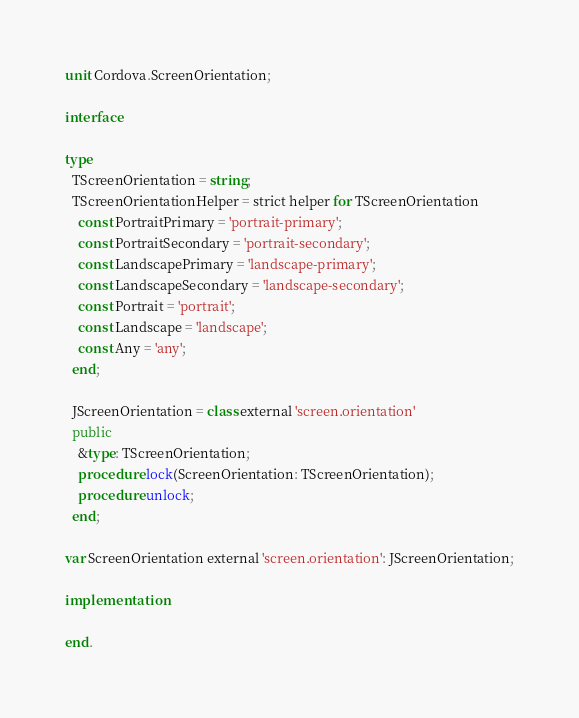Convert code to text. <code><loc_0><loc_0><loc_500><loc_500><_Pascal_>unit Cordova.ScreenOrientation;

interface

type
  TScreenOrientation = string;
  TScreenOrientationHelper = strict helper for TScreenOrientation
    const PortraitPrimary = 'portrait-primary';
    const PortraitSecondary = 'portrait-secondary';
    const LandscapePrimary = 'landscape-primary';
    const LandscapeSecondary = 'landscape-secondary';
    const Portrait = 'portrait';
    const Landscape = 'landscape';
    const Any = 'any';
  end;

  JScreenOrientation = class external 'screen.orientation'
  public
    &type: TScreenOrientation;
    procedure lock(ScreenOrientation: TScreenOrientation);
    procedure unlock;
  end;
  
var ScreenOrientation external 'screen.orientation': JScreenOrientation;

implementation

end.</code> 